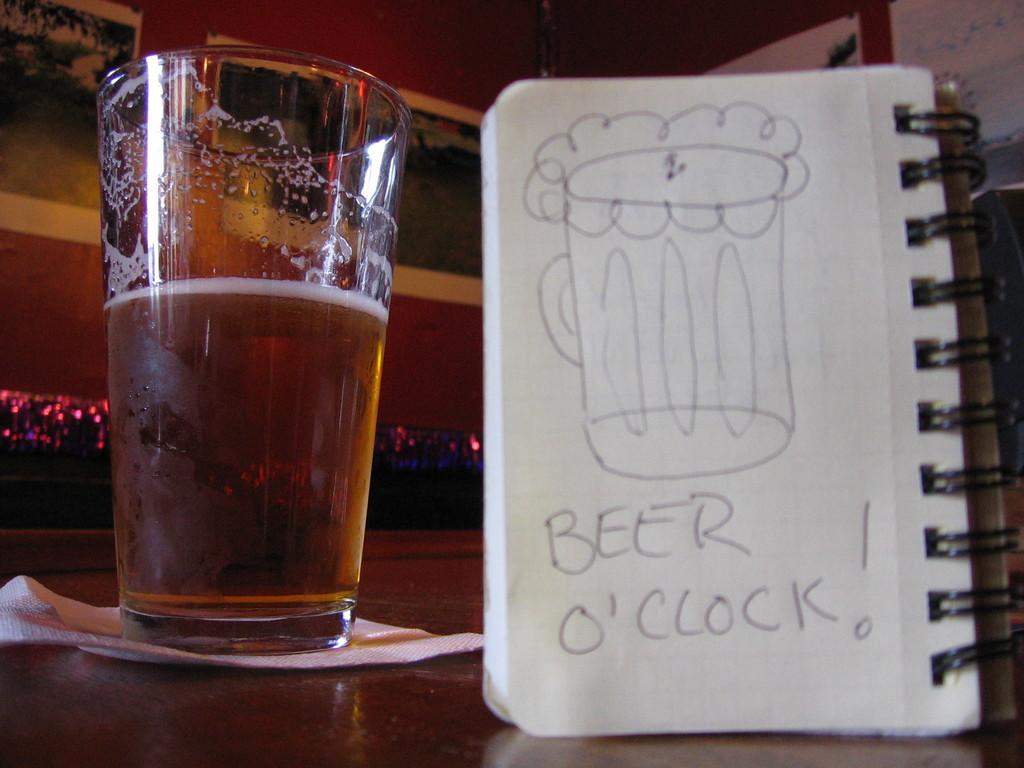What is written on the pad of paper?
Ensure brevity in your answer.  Beer o'clock. 